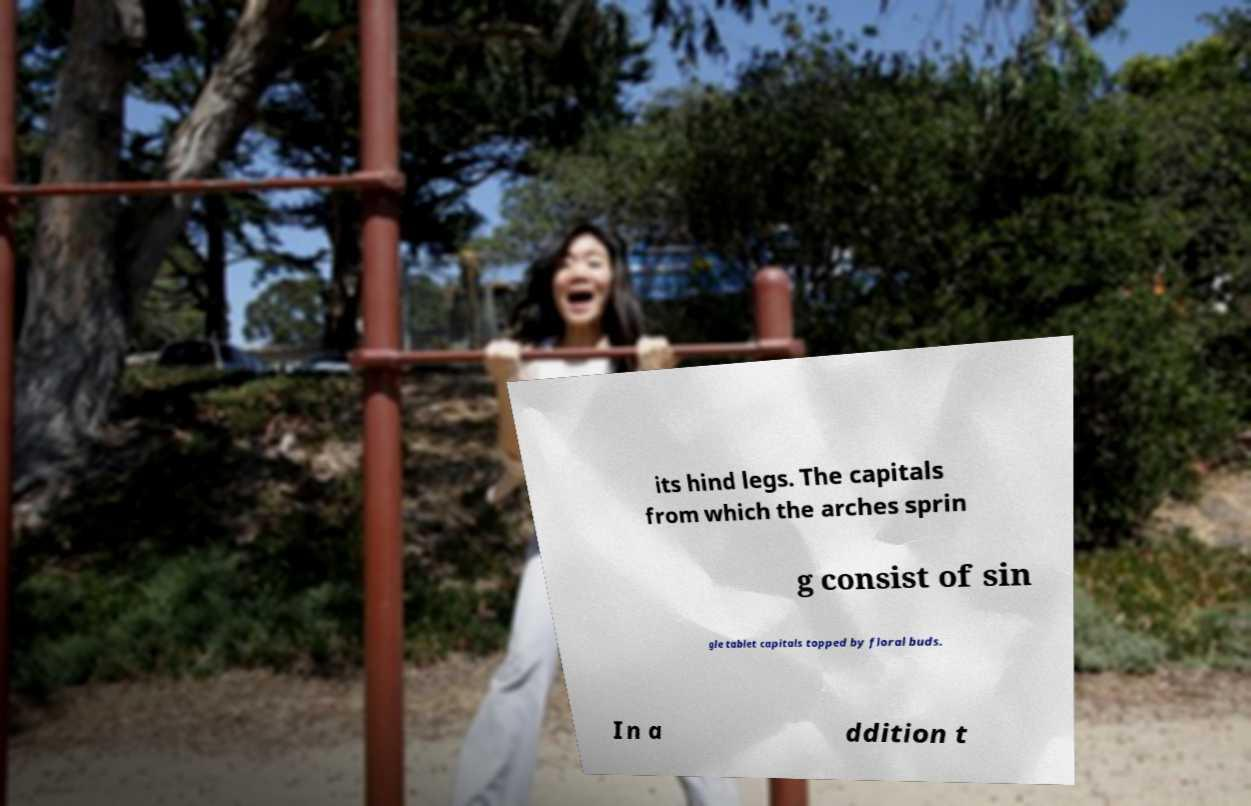For documentation purposes, I need the text within this image transcribed. Could you provide that? its hind legs. The capitals from which the arches sprin g consist of sin gle tablet capitals topped by floral buds. In a ddition t 